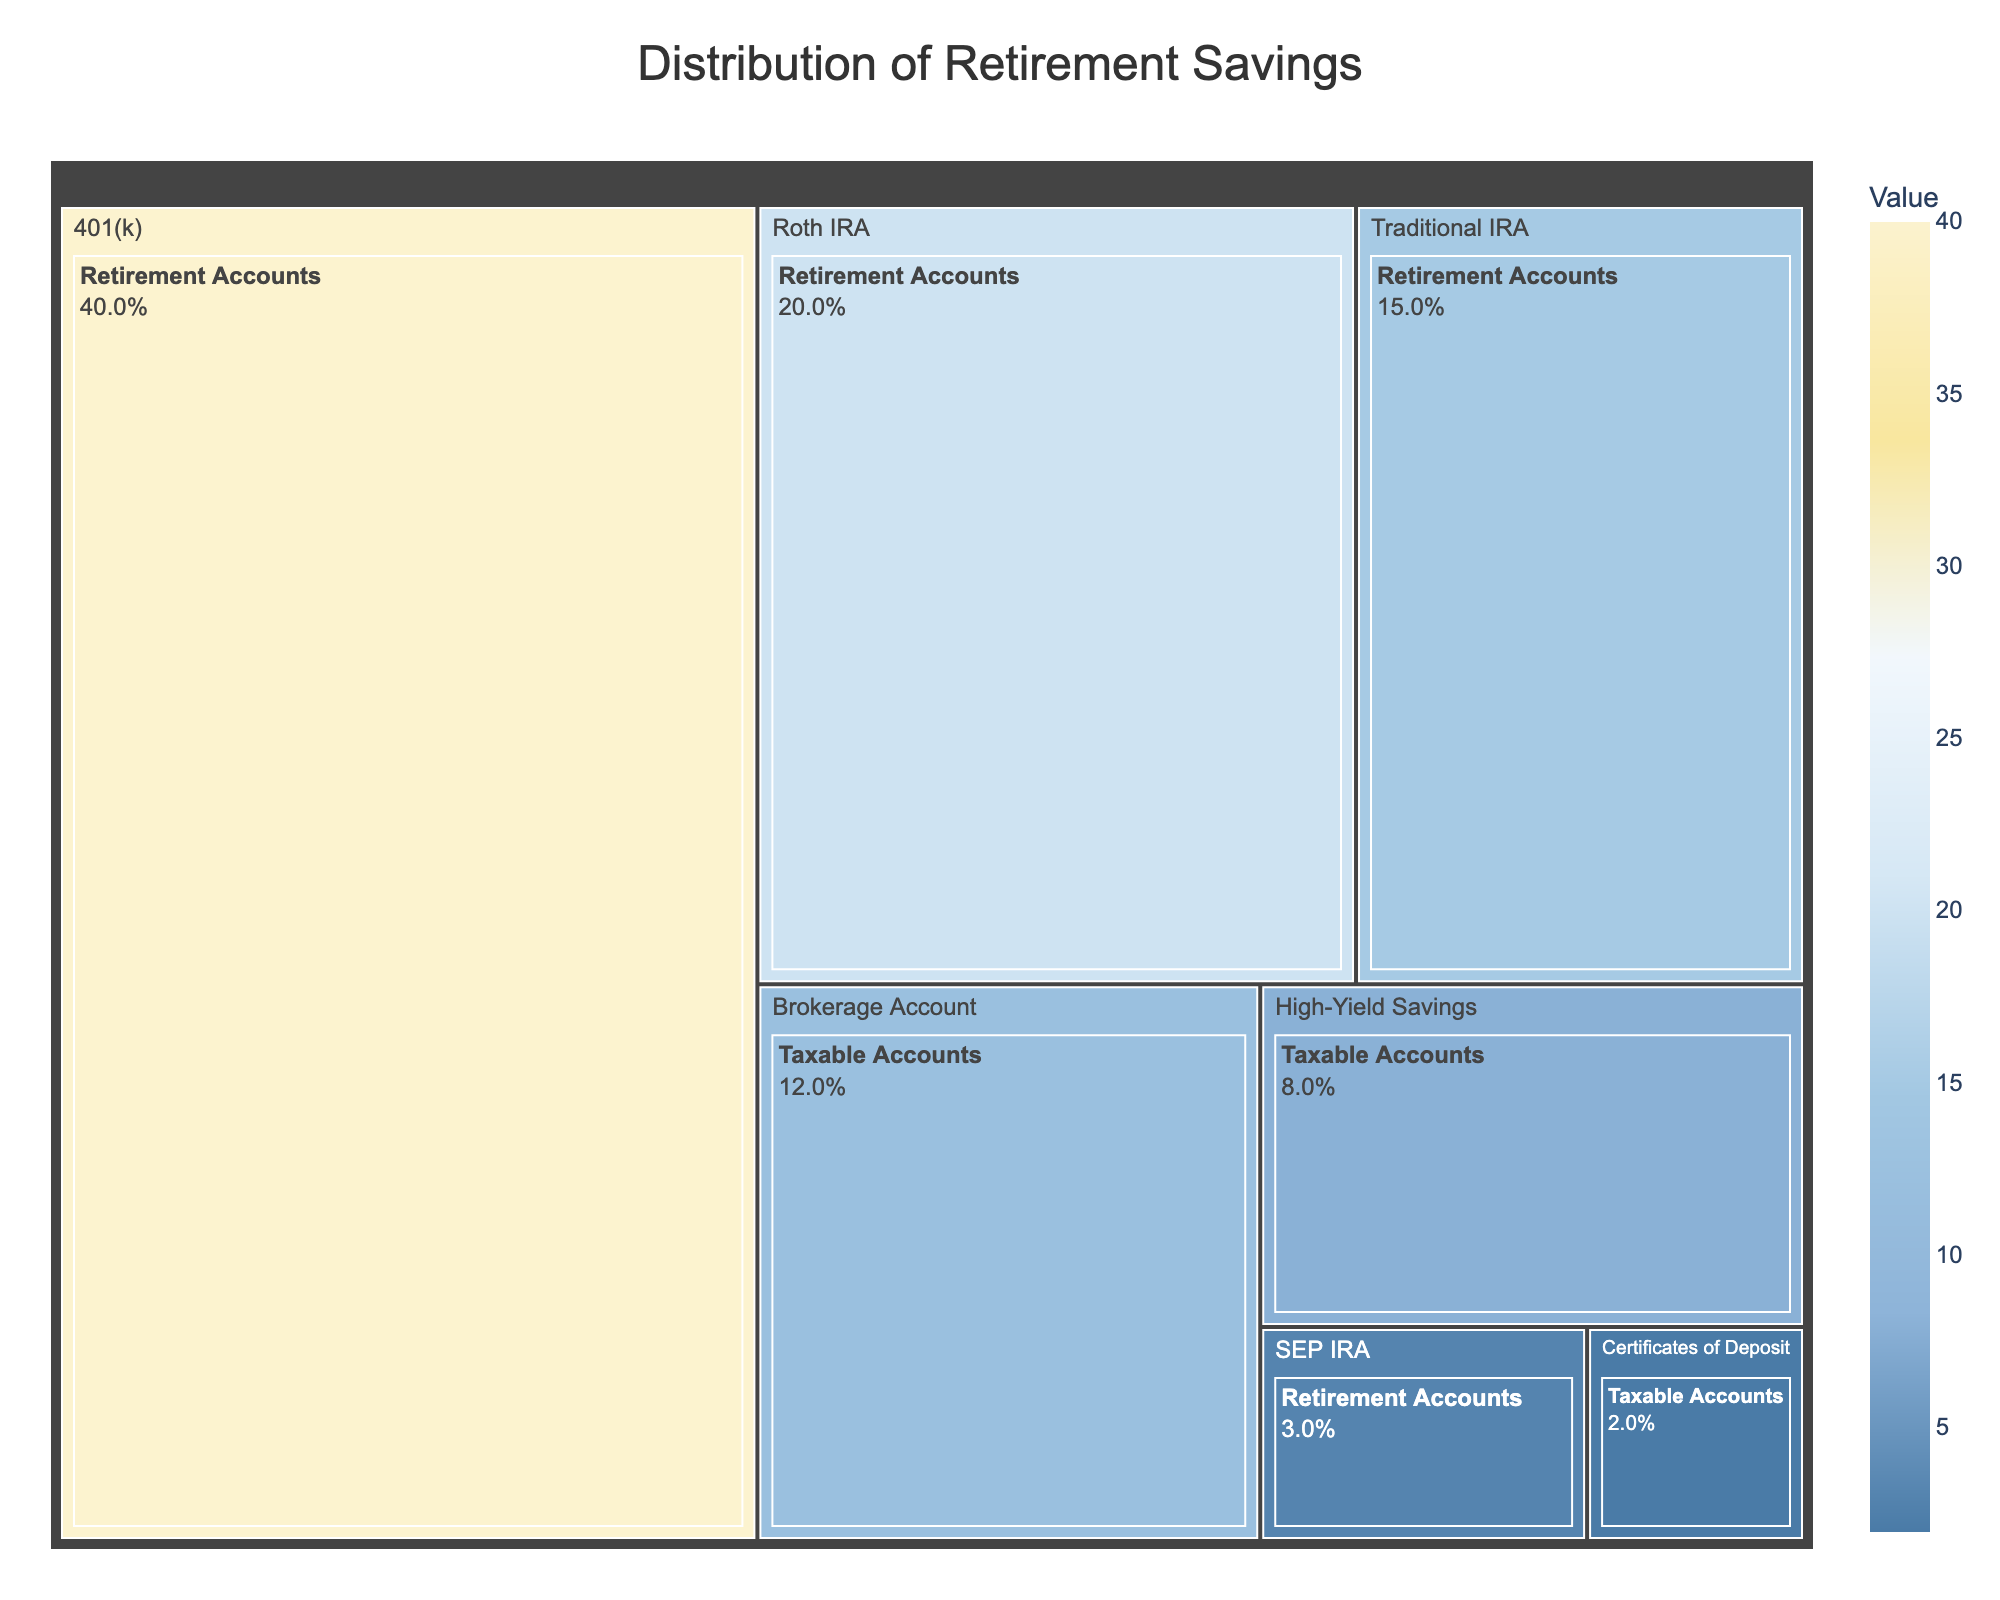What is the title of the treemap? The title is located at the top center of the figure. It clearly states the main topic represented by the treemap.
Answer: Distribution of Retirement Savings Which investment category has the highest value? By observing the sizes of the tiles in the treemap, the one with the largest area corresponds to the highest value.
Answer: 401(k) How much value does the Roth IRA have? Locate the tile labeled as Roth IRA in the figure and refer to its corresponding value.
Answer: 20 What is the combined value of all Taxable Accounts? Sum the values of Brokerage Account, High-Yield Savings, and Certificates of Deposit to get the combined value. 12 + 8 + 2 = 22.
Answer: 22 Which has a higher value: Traditional IRA or Brokerage Account? Compare the values of the Traditional IRA and Brokerage Account by visually inspecting their respective labels in the treemap.
Answer: Traditional IRA What is the smallest investment type category, and what is its value? Identify the smallest tile in the treemap by its size and then look at the label to confirm the category and view its value.
Answer: Certificates of Deposit, 2 Which account type has the lowest value within the Retirement Accounts category? Look within the Retirement Accounts category tiles and identify the one with the smallest area.
Answer: SEP IRA What percentage of the total retirement savings does the 401(k) represent? First calculate the total value of retirement savings (40 + 15 + 20 + 3 = 78). Then, compute the percentage using the value of 401(k) (40 / 78 * 100 ≈ 51.3%).
Answer: Approximately 51.3% How does the value of High-Yield Savings compare to that of SEP IRA? Compare the values by examining their respective areas in the treemap. High-Yield Savings has a value of 8, while SEP IRA has a value of 3, so High-Yield Savings is larger.
Answer: High-Yield Savings Which investment type appears most frequently in the treemap? Count the instances of each investment type in the treemap. The most frequent one has the highest count.
Answer: Retirement Accounts 